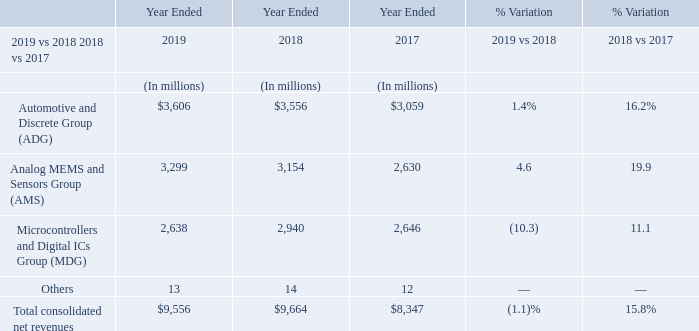For the full year 2019, our ADG revenues increased 1.4% compared to the previous period. The increase was primarily due to improved average selling prices of approximately 9%, which was entirely due to a better product mix, and partially offset by a decrease in volumes by approximately 8%.
AMS revenues grew 4.6%, mainly due to the double-digits growth in Imaging. The increase was due to higher average selling prices of approximately 12%, as a result of a better product mix, and was partially offset by lower volumes of approximately 7%.
MDG revenues were down by 10.3%, mainly due to Microcontrollers. The decrease was due to lower volumes of approximately 10% while average selling prices remained substantially flat.
In 2018, all product groups registered double-digit revenue increase. Our ADG revenues increased 16.2% for the full year 2018 compared to the full year 2017 on growth in both Power Discrete and Automotive. The increase was primarily due to improved average selling prices of approximately 21% and volumes decreased by approximately 5%. The increase in average selling prices was entirely due to improved product mix, while selling prices remained substantially flat.
AMS revenues grew 19.9%, mainly on the strong increase in Imaging. The increase was due to higher volumes of approximately 12% and higher average selling prices of approximately 8%, which was entirely due to improved product mix of approximately 13%, while selling prices decreased by approximately 5%.
MDG revenues were up by 11.1%, with Digital and Microcontrollers & Memories equally contributing. The increase was primarily due to higher average selling prices of approximately 11%, while volumes remained substantially flat. The increase in average selling prices was due to a better product mix of approximately 13%, while the selling prices effect was negative of approximately 2%.
In 2019, what was the reason for increase in ADG revenues? The increase was primarily due to improved average selling prices of approximately 9%, which was entirely due to a better product mix, and partially offset by a decrease in volumes by approximately 8%. In 2019, what was the reason for increase in AMS revenues? Ams revenues grew 4.6%, mainly due to the double-digits growth in imaging. the increase was due to higher average selling prices of approximately 12%, as a result of a better product mix, and was partially offset by lower volumes of approximately 7%. In 2019, what was the reason for fall in MDG revenues? Mdg revenues were down by 10.3%, mainly due to microcontrollers. the decrease was due to lower volumes of approximately 10% while average selling prices remained substantially flat. What are the average net revenues by Automotive and Discrete Group (ADG)?
Answer scale should be: million. (3,606+3,556+3,059) / 3
Answer: 3407. What are the average net revenues by Analog MEMS and Sensors Group (AMS)?
Answer scale should be: million. (3,299+3,154+2,630) / 3
Answer: 3027.67. What are the average net revenues by Microcontrollers and Digital ICs Group (MDG)?
Answer scale should be: million. (2,638+2,940+2,646) / 3
Answer: 2741.33. 